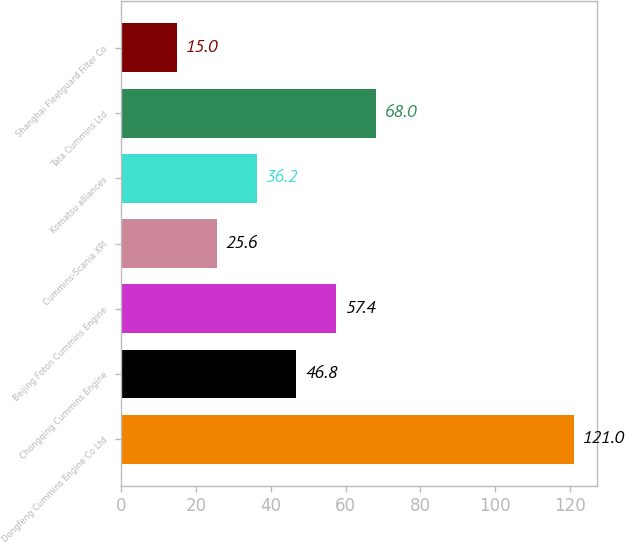<chart> <loc_0><loc_0><loc_500><loc_500><bar_chart><fcel>Dongfeng Cummins Engine Co Ltd<fcel>Chongqing Cummins Engine<fcel>Beijing Foton Cummins Engine<fcel>Cummins-Scania XPI<fcel>Komatsu alliances<fcel>Tata Cummins Ltd<fcel>Shanghai Fleetguard Filter Co<nl><fcel>121<fcel>46.8<fcel>57.4<fcel>25.6<fcel>36.2<fcel>68<fcel>15<nl></chart> 